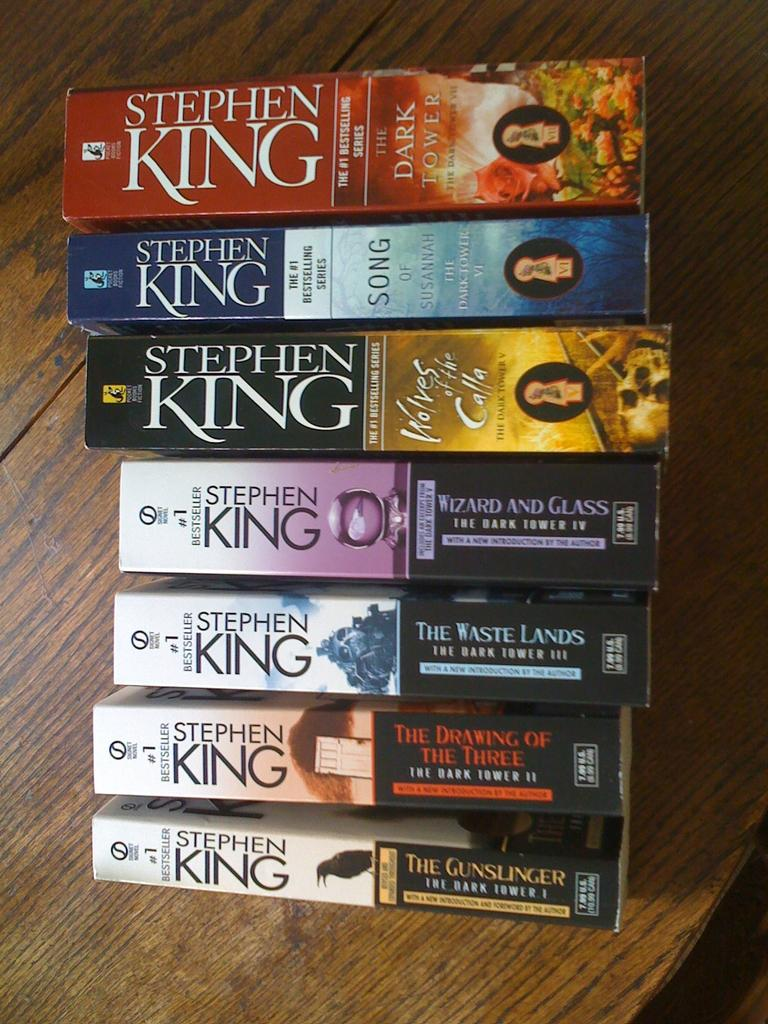<image>
Present a compact description of the photo's key features. A stack of Stephen King paperbacks promise scary reading for a long time. 